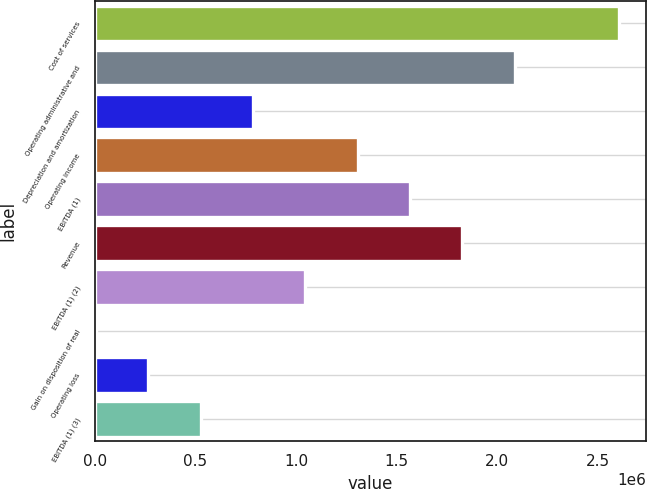<chart> <loc_0><loc_0><loc_500><loc_500><bar_chart><fcel>Cost of services<fcel>Operating administrative and<fcel>Depreciation and amortization<fcel>Operating income<fcel>EBITDA (1)<fcel>Revenue<fcel>EBITDA (1) (2)<fcel>Gain on disposition of real<fcel>Operating loss<fcel>EBITDA (1) (3)<nl><fcel>2.60703e+06<fcel>2.0868e+06<fcel>786225<fcel>1.30646e+06<fcel>1.56657e+06<fcel>1.82668e+06<fcel>1.04634e+06<fcel>5881<fcel>265996<fcel>526111<nl></chart> 